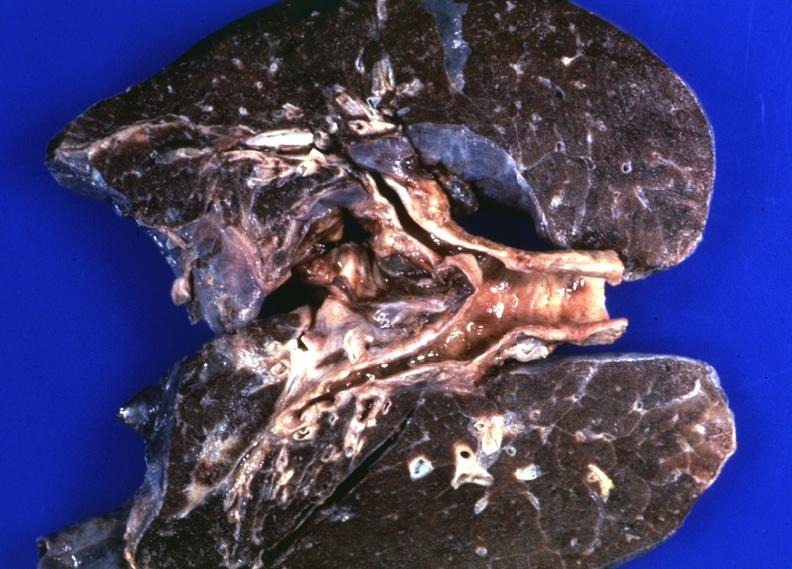s respiratory present?
Answer the question using a single word or phrase. Yes 